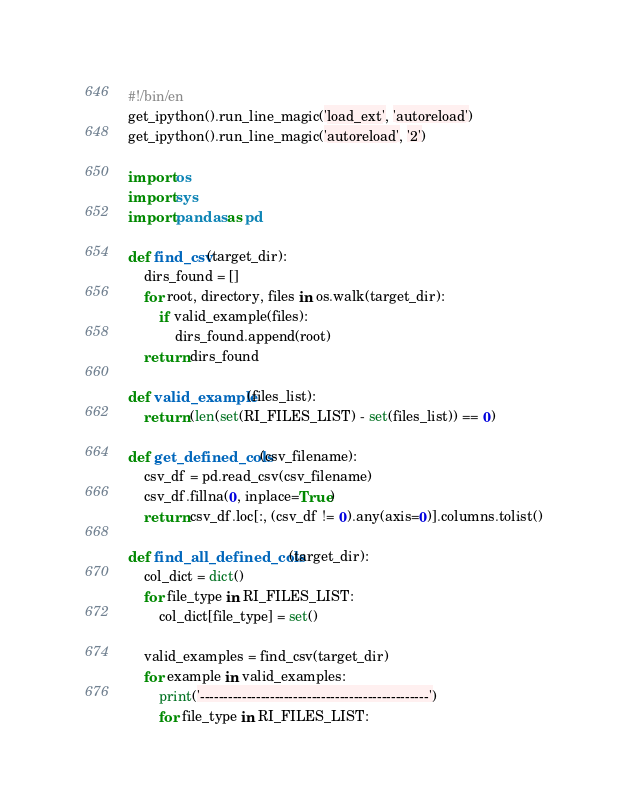Convert code to text. <code><loc_0><loc_0><loc_500><loc_500><_Python_>#!/bin/en
get_ipython().run_line_magic('load_ext', 'autoreload')
get_ipython().run_line_magic('autoreload', '2')

import os 
import sys
import pandas as pd

def find_csv(target_dir):
    dirs_found = []
    for root, directory, files in os.walk(target_dir):
        if valid_example(files):
            dirs_found.append(root)
    return dirs_found        

def valid_example(files_list):
    return (len(set(RI_FILES_LIST) - set(files_list)) == 0)

def get_defined_cols(csv_filename):
    csv_df = pd.read_csv(csv_filename)
    csv_df.fillna(0, inplace=True)
    return csv_df.loc[:, (csv_df != 0).any(axis=0)].columns.tolist()

def find_all_defined_cols(target_dir):
    col_dict = dict()
    for file_type in RI_FILES_LIST:
        col_dict[file_type] = set()

    valid_examples = find_csv(target_dir)
    for example in valid_examples:
        print('-------------------------------------------------')
        for file_type in RI_FILES_LIST:</code> 